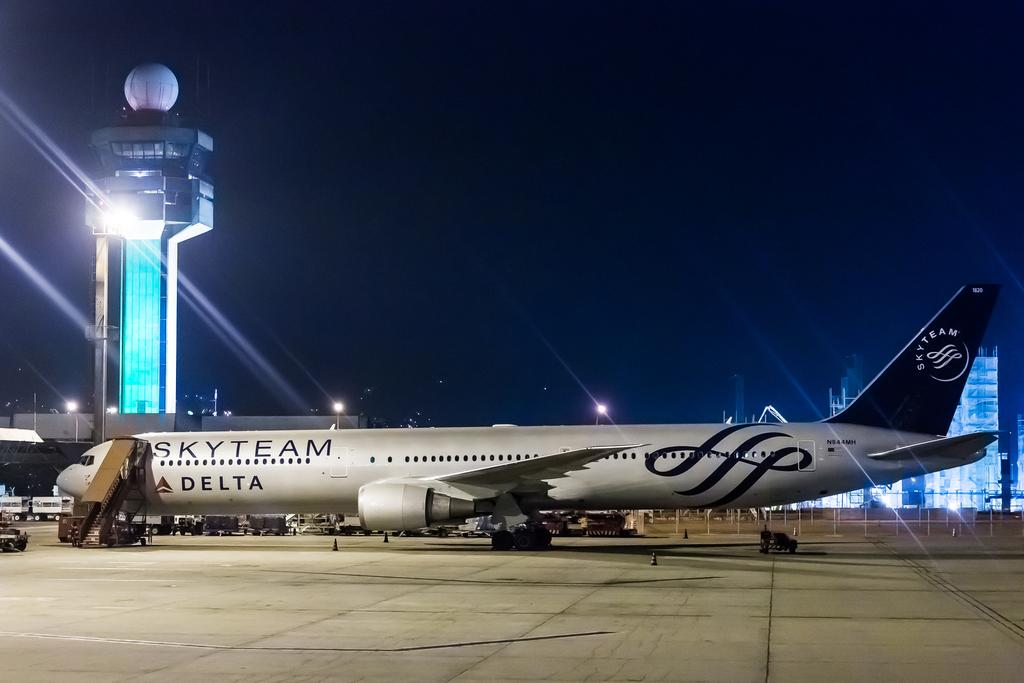<image>
Relay a brief, clear account of the picture shown. A Skyteam Delta airplane sitting at an airport at night 